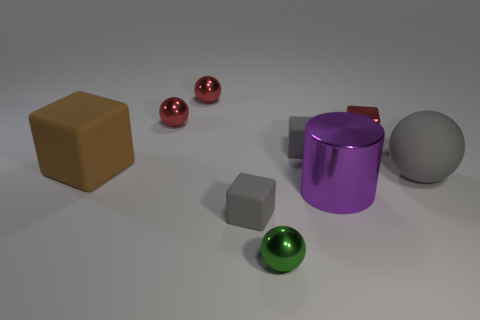What number of metallic things are either red spheres or tiny red cubes?
Give a very brief answer. 3. What material is the thing to the right of the cube on the right side of the small matte object that is right of the green thing?
Provide a short and direct response. Rubber. The small green sphere that is in front of the gray rubber block that is behind the big gray sphere is made of what material?
Offer a terse response. Metal. There is a gray object in front of the large purple thing; is its size the same as the red cube on the right side of the tiny green shiny sphere?
Make the answer very short. Yes. Are there any other things that are the same material as the large block?
Provide a succinct answer. Yes. How many tiny objects are either green objects or metal things?
Offer a very short reply. 4. What number of objects are either small spheres that are in front of the big rubber cube or yellow cylinders?
Keep it short and to the point. 1. Does the cylinder have the same color as the big sphere?
Provide a short and direct response. No. What number of other objects are there of the same shape as the tiny green metal thing?
Offer a very short reply. 3. How many red objects are tiny blocks or shiny things?
Provide a short and direct response. 3. 